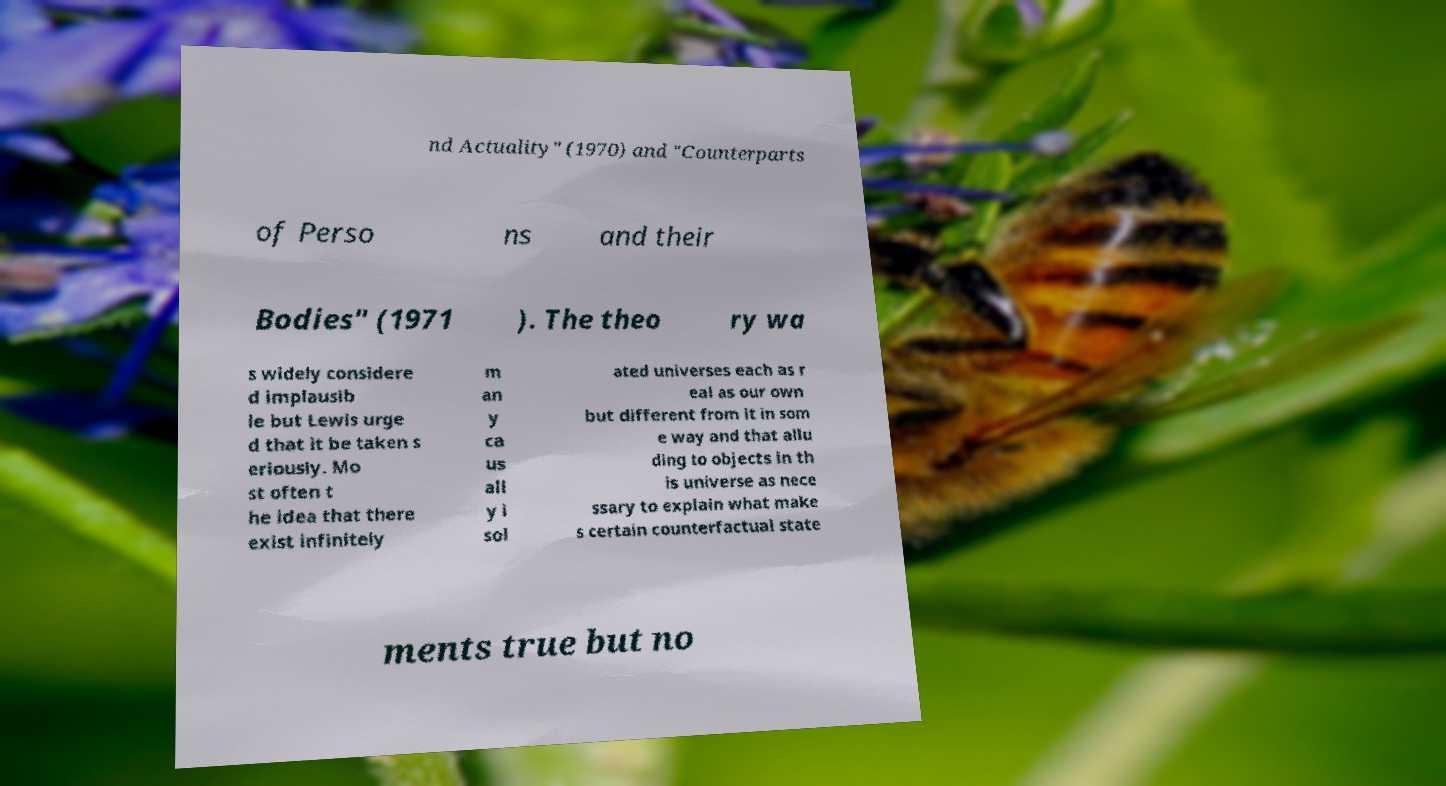Could you assist in decoding the text presented in this image and type it out clearly? nd Actuality" (1970) and "Counterparts of Perso ns and their Bodies" (1971 ). The theo ry wa s widely considere d implausib le but Lewis urge d that it be taken s eriously. Mo st often t he idea that there exist infinitely m an y ca us all y i sol ated universes each as r eal as our own but different from it in som e way and that allu ding to objects in th is universe as nece ssary to explain what make s certain counterfactual state ments true but no 